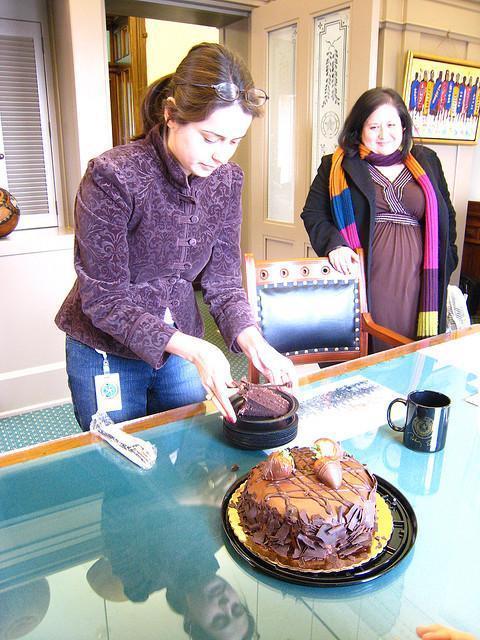How many people are there?
Give a very brief answer. 2. 